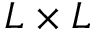Convert formula to latex. <formula><loc_0><loc_0><loc_500><loc_500>L \times L</formula> 